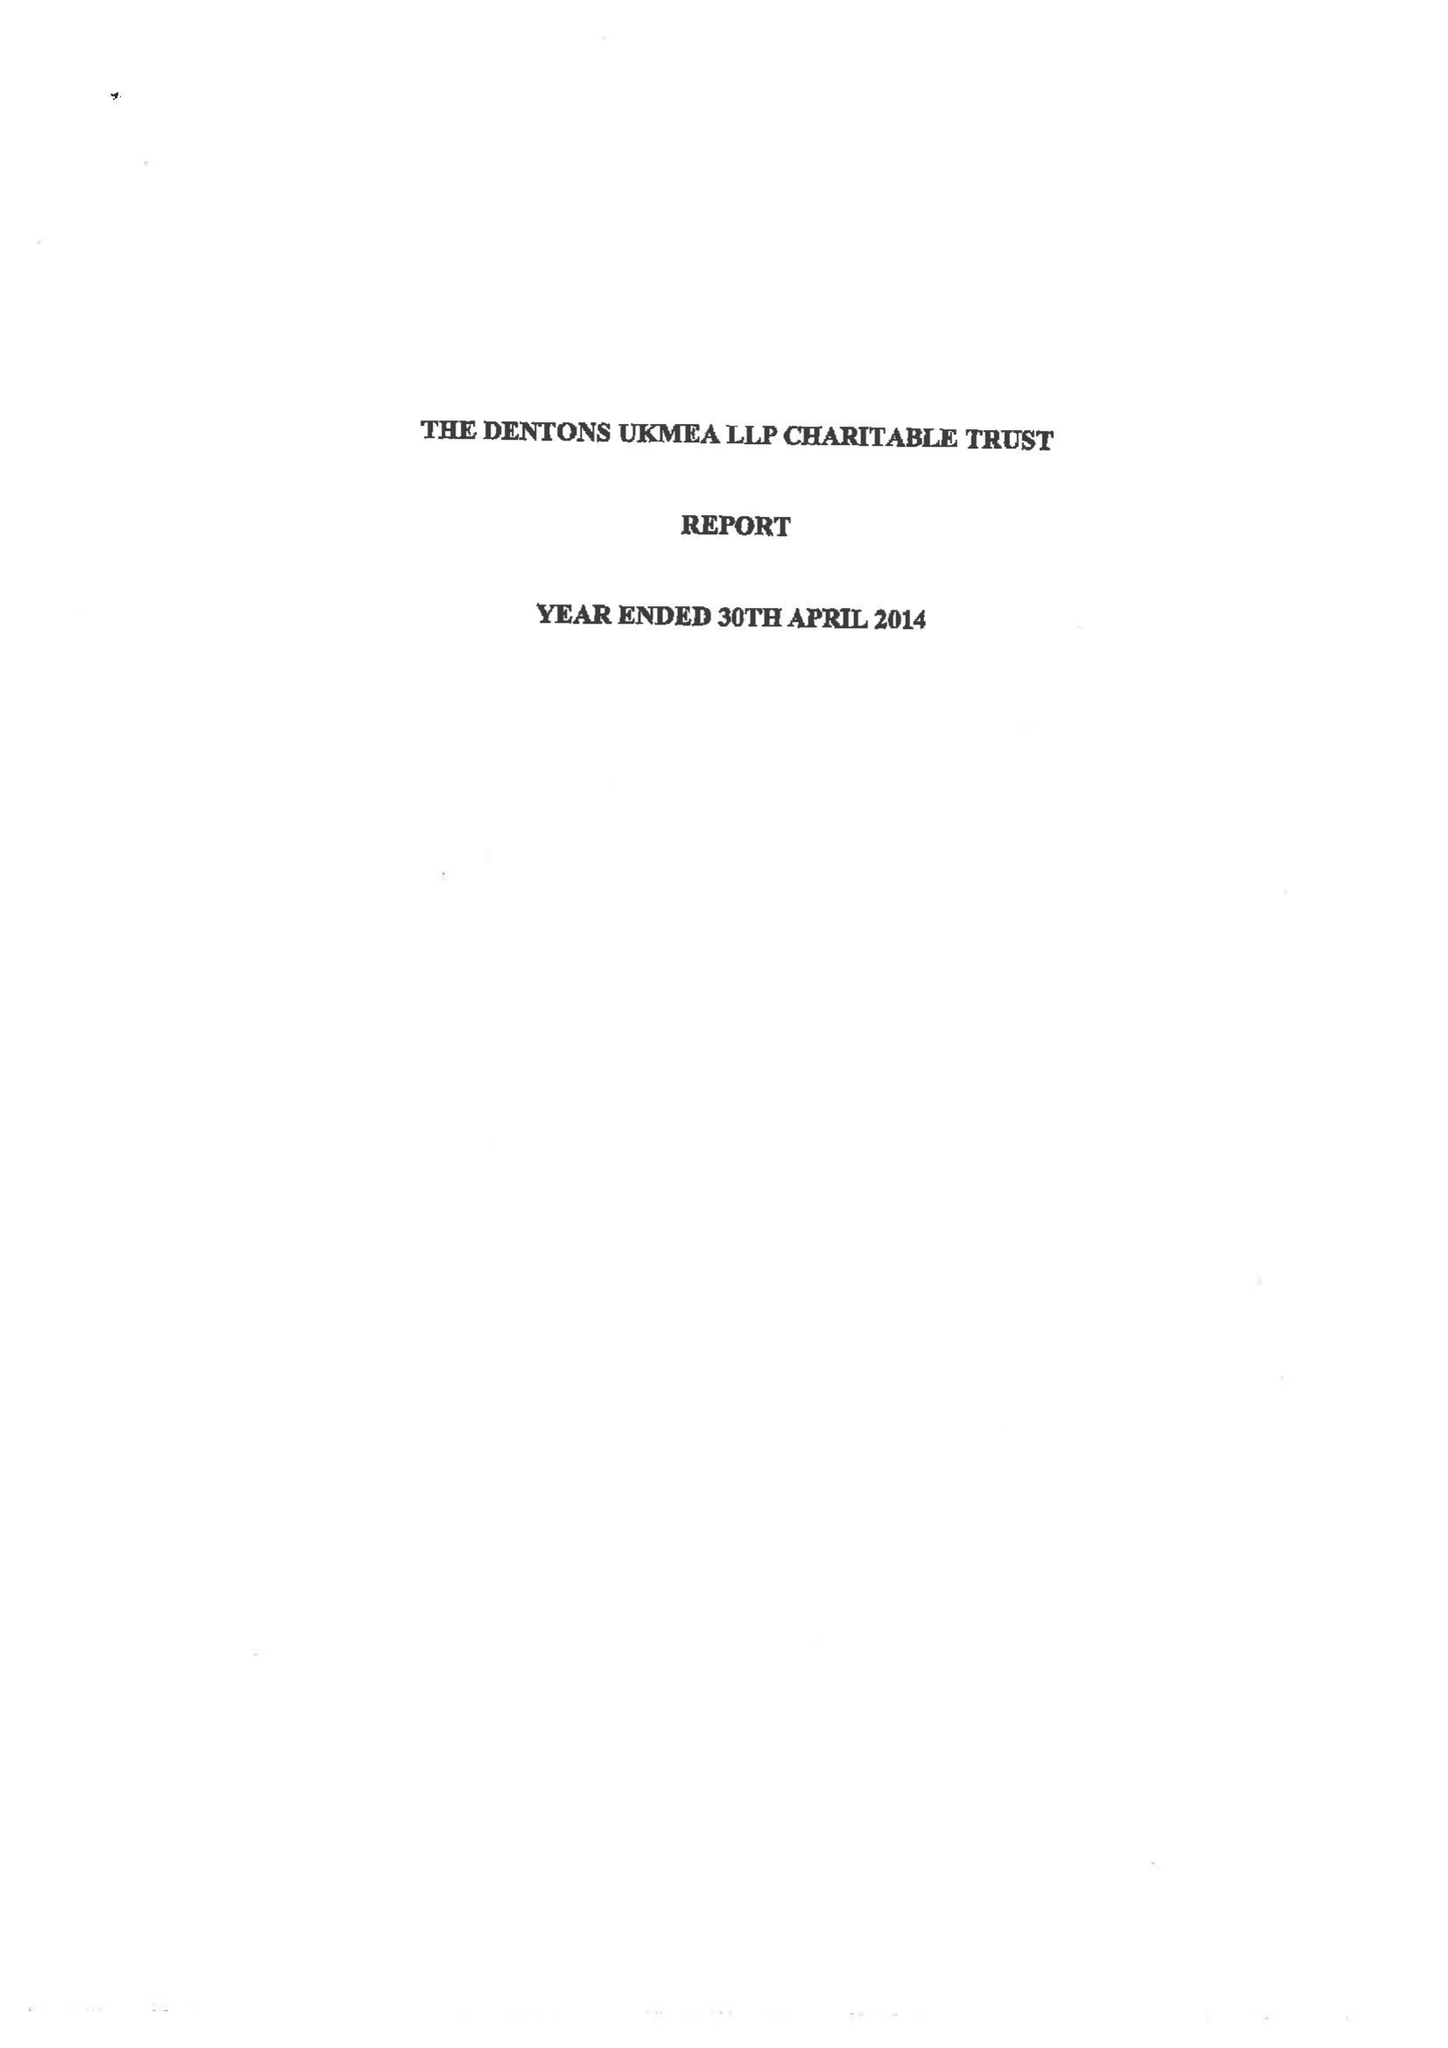What is the value for the address__post_town?
Answer the question using a single word or phrase. LONDON 